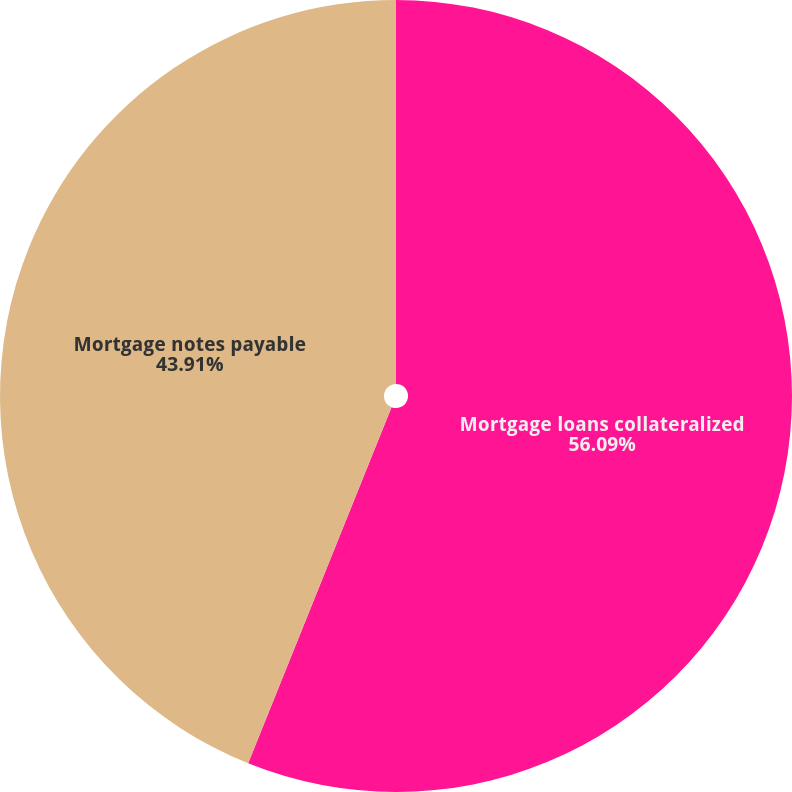Convert chart. <chart><loc_0><loc_0><loc_500><loc_500><pie_chart><fcel>Mortgage loans collateralized<fcel>Mortgage notes payable<nl><fcel>56.09%<fcel>43.91%<nl></chart> 